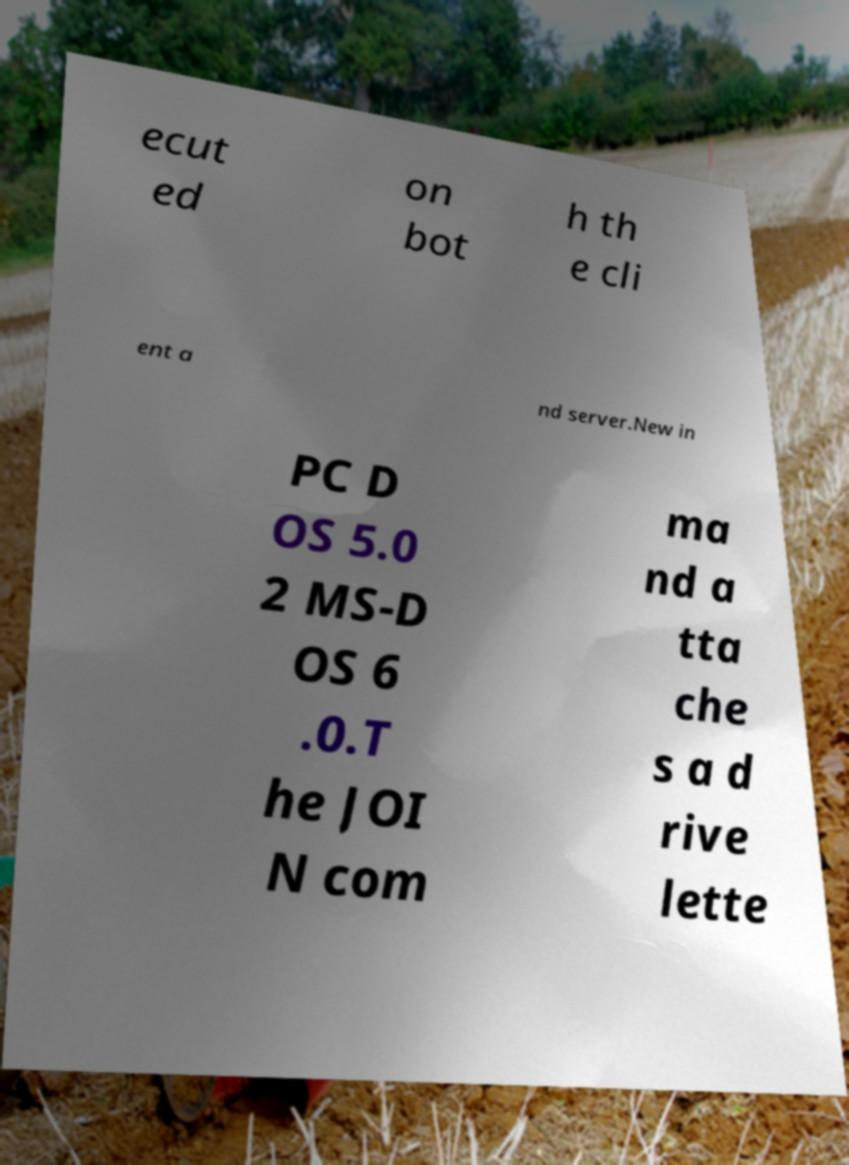For documentation purposes, I need the text within this image transcribed. Could you provide that? ecut ed on bot h th e cli ent a nd server.New in PC D OS 5.0 2 MS-D OS 6 .0.T he JOI N com ma nd a tta che s a d rive lette 